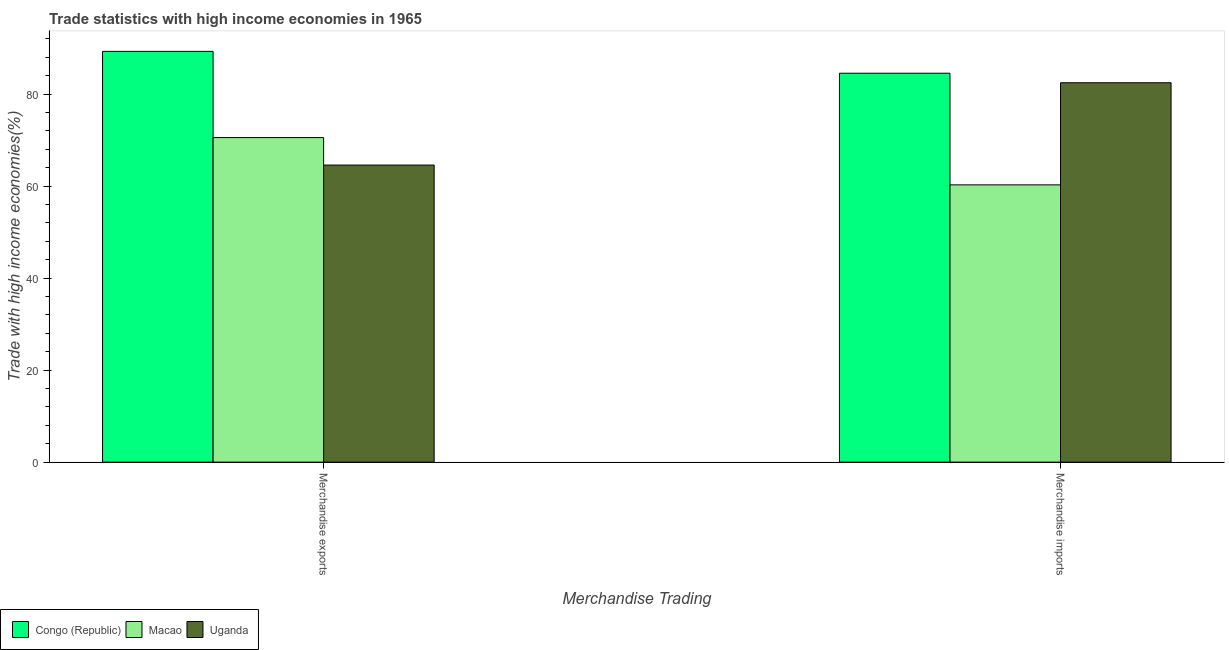How many different coloured bars are there?
Provide a succinct answer. 3. Are the number of bars on each tick of the X-axis equal?
Offer a terse response. Yes. How many bars are there on the 2nd tick from the left?
Your answer should be very brief. 3. How many bars are there on the 2nd tick from the right?
Offer a very short reply. 3. What is the merchandise imports in Uganda?
Your answer should be compact. 82.45. Across all countries, what is the maximum merchandise imports?
Provide a short and direct response. 84.52. Across all countries, what is the minimum merchandise exports?
Offer a very short reply. 64.56. In which country was the merchandise imports maximum?
Offer a terse response. Congo (Republic). In which country was the merchandise imports minimum?
Ensure brevity in your answer.  Macao. What is the total merchandise exports in the graph?
Provide a succinct answer. 224.36. What is the difference between the merchandise imports in Uganda and that in Congo (Republic)?
Offer a terse response. -2.07. What is the difference between the merchandise imports in Macao and the merchandise exports in Uganda?
Offer a very short reply. -4.3. What is the average merchandise imports per country?
Give a very brief answer. 75.74. What is the difference between the merchandise exports and merchandise imports in Congo (Republic)?
Keep it short and to the point. 4.75. In how many countries, is the merchandise exports greater than 16 %?
Offer a terse response. 3. What is the ratio of the merchandise imports in Uganda to that in Congo (Republic)?
Your answer should be compact. 0.98. In how many countries, is the merchandise exports greater than the average merchandise exports taken over all countries?
Your answer should be very brief. 1. What does the 2nd bar from the left in Merchandise exports represents?
Provide a succinct answer. Macao. What does the 3rd bar from the right in Merchandise imports represents?
Your response must be concise. Congo (Republic). How many bars are there?
Offer a very short reply. 6. Are all the bars in the graph horizontal?
Provide a short and direct response. No. What is the difference between two consecutive major ticks on the Y-axis?
Provide a short and direct response. 20. Are the values on the major ticks of Y-axis written in scientific E-notation?
Keep it short and to the point. No. Does the graph contain grids?
Your response must be concise. No. Where does the legend appear in the graph?
Make the answer very short. Bottom left. How many legend labels are there?
Your response must be concise. 3. How are the legend labels stacked?
Offer a very short reply. Horizontal. What is the title of the graph?
Offer a terse response. Trade statistics with high income economies in 1965. What is the label or title of the X-axis?
Make the answer very short. Merchandise Trading. What is the label or title of the Y-axis?
Provide a succinct answer. Trade with high income economies(%). What is the Trade with high income economies(%) of Congo (Republic) in Merchandise exports?
Your answer should be compact. 89.27. What is the Trade with high income economies(%) of Macao in Merchandise exports?
Your answer should be very brief. 70.53. What is the Trade with high income economies(%) of Uganda in Merchandise exports?
Keep it short and to the point. 64.56. What is the Trade with high income economies(%) of Congo (Republic) in Merchandise imports?
Ensure brevity in your answer.  84.52. What is the Trade with high income economies(%) of Macao in Merchandise imports?
Give a very brief answer. 60.26. What is the Trade with high income economies(%) of Uganda in Merchandise imports?
Make the answer very short. 82.45. Across all Merchandise Trading, what is the maximum Trade with high income economies(%) in Congo (Republic)?
Your answer should be very brief. 89.27. Across all Merchandise Trading, what is the maximum Trade with high income economies(%) of Macao?
Offer a terse response. 70.53. Across all Merchandise Trading, what is the maximum Trade with high income economies(%) in Uganda?
Ensure brevity in your answer.  82.45. Across all Merchandise Trading, what is the minimum Trade with high income economies(%) in Congo (Republic)?
Ensure brevity in your answer.  84.52. Across all Merchandise Trading, what is the minimum Trade with high income economies(%) of Macao?
Offer a terse response. 60.26. Across all Merchandise Trading, what is the minimum Trade with high income economies(%) in Uganda?
Your answer should be compact. 64.56. What is the total Trade with high income economies(%) in Congo (Republic) in the graph?
Offer a terse response. 173.79. What is the total Trade with high income economies(%) in Macao in the graph?
Your answer should be compact. 130.79. What is the total Trade with high income economies(%) in Uganda in the graph?
Keep it short and to the point. 147.01. What is the difference between the Trade with high income economies(%) in Congo (Republic) in Merchandise exports and that in Merchandise imports?
Keep it short and to the point. 4.75. What is the difference between the Trade with high income economies(%) in Macao in Merchandise exports and that in Merchandise imports?
Make the answer very short. 10.28. What is the difference between the Trade with high income economies(%) in Uganda in Merchandise exports and that in Merchandise imports?
Ensure brevity in your answer.  -17.89. What is the difference between the Trade with high income economies(%) in Congo (Republic) in Merchandise exports and the Trade with high income economies(%) in Macao in Merchandise imports?
Your answer should be very brief. 29.01. What is the difference between the Trade with high income economies(%) of Congo (Republic) in Merchandise exports and the Trade with high income economies(%) of Uganda in Merchandise imports?
Your answer should be compact. 6.82. What is the difference between the Trade with high income economies(%) in Macao in Merchandise exports and the Trade with high income economies(%) in Uganda in Merchandise imports?
Your answer should be compact. -11.92. What is the average Trade with high income economies(%) in Congo (Republic) per Merchandise Trading?
Your answer should be compact. 86.9. What is the average Trade with high income economies(%) of Macao per Merchandise Trading?
Provide a short and direct response. 65.39. What is the average Trade with high income economies(%) of Uganda per Merchandise Trading?
Offer a very short reply. 73.5. What is the difference between the Trade with high income economies(%) in Congo (Republic) and Trade with high income economies(%) in Macao in Merchandise exports?
Your answer should be very brief. 18.74. What is the difference between the Trade with high income economies(%) in Congo (Republic) and Trade with high income economies(%) in Uganda in Merchandise exports?
Your answer should be very brief. 24.71. What is the difference between the Trade with high income economies(%) in Macao and Trade with high income economies(%) in Uganda in Merchandise exports?
Your response must be concise. 5.97. What is the difference between the Trade with high income economies(%) of Congo (Republic) and Trade with high income economies(%) of Macao in Merchandise imports?
Provide a succinct answer. 24.26. What is the difference between the Trade with high income economies(%) in Congo (Republic) and Trade with high income economies(%) in Uganda in Merchandise imports?
Offer a very short reply. 2.07. What is the difference between the Trade with high income economies(%) in Macao and Trade with high income economies(%) in Uganda in Merchandise imports?
Ensure brevity in your answer.  -22.2. What is the ratio of the Trade with high income economies(%) in Congo (Republic) in Merchandise exports to that in Merchandise imports?
Offer a very short reply. 1.06. What is the ratio of the Trade with high income economies(%) of Macao in Merchandise exports to that in Merchandise imports?
Make the answer very short. 1.17. What is the ratio of the Trade with high income economies(%) of Uganda in Merchandise exports to that in Merchandise imports?
Ensure brevity in your answer.  0.78. What is the difference between the highest and the second highest Trade with high income economies(%) of Congo (Republic)?
Ensure brevity in your answer.  4.75. What is the difference between the highest and the second highest Trade with high income economies(%) of Macao?
Ensure brevity in your answer.  10.28. What is the difference between the highest and the second highest Trade with high income economies(%) of Uganda?
Your response must be concise. 17.89. What is the difference between the highest and the lowest Trade with high income economies(%) of Congo (Republic)?
Offer a very short reply. 4.75. What is the difference between the highest and the lowest Trade with high income economies(%) in Macao?
Provide a short and direct response. 10.28. What is the difference between the highest and the lowest Trade with high income economies(%) of Uganda?
Provide a short and direct response. 17.89. 